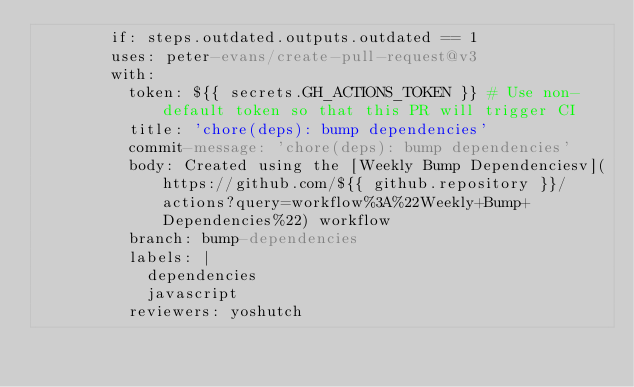Convert code to text. <code><loc_0><loc_0><loc_500><loc_500><_YAML_>        if: steps.outdated.outputs.outdated == 1
        uses: peter-evans/create-pull-request@v3
        with:
          token: ${{ secrets.GH_ACTIONS_TOKEN }} # Use non-default token so that this PR will trigger CI
          title: 'chore(deps): bump dependencies'
          commit-message: 'chore(deps): bump dependencies'
          body: Created using the [Weekly Bump Dependenciesv](https://github.com/${{ github.repository }}/actions?query=workflow%3A%22Weekly+Bump+Dependencies%22) workflow
          branch: bump-dependencies
          labels: |
            dependencies
            javascript
          reviewers: yoshutch
</code> 